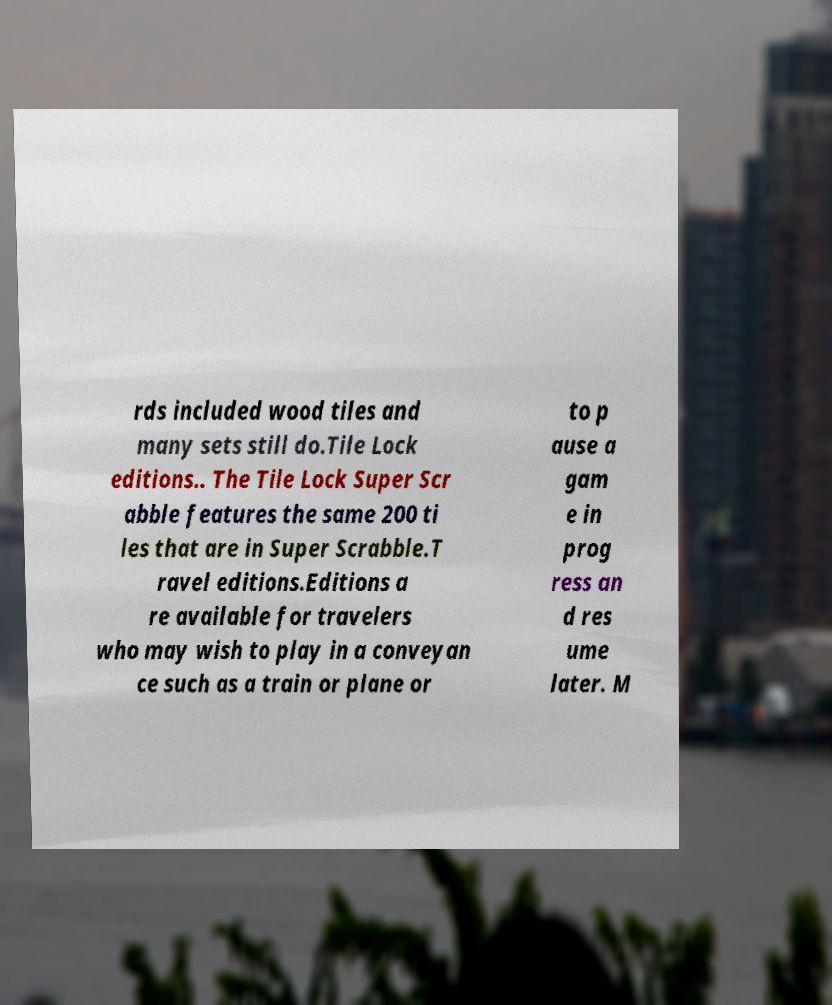I need the written content from this picture converted into text. Can you do that? rds included wood tiles and many sets still do.Tile Lock editions.. The Tile Lock Super Scr abble features the same 200 ti les that are in Super Scrabble.T ravel editions.Editions a re available for travelers who may wish to play in a conveyan ce such as a train or plane or to p ause a gam e in prog ress an d res ume later. M 